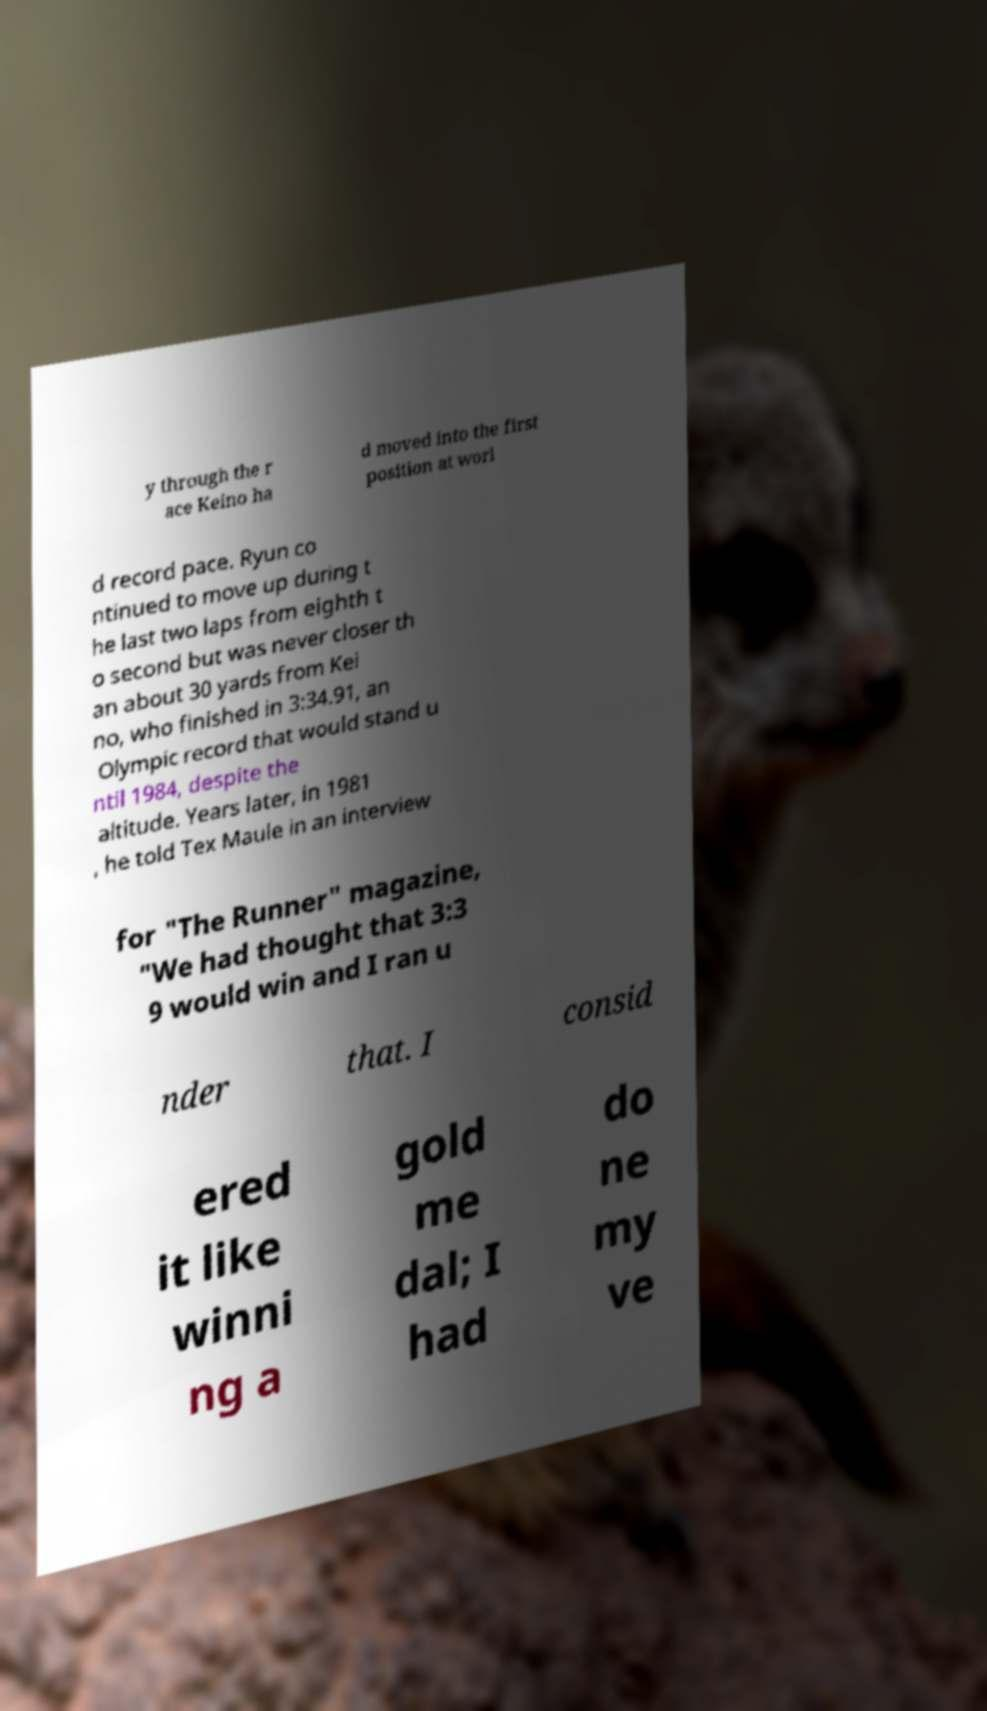Please read and relay the text visible in this image. What does it say? y through the r ace Keino ha d moved into the first position at worl d record pace. Ryun co ntinued to move up during t he last two laps from eighth t o second but was never closer th an about 30 yards from Kei no, who finished in 3:34.91, an Olympic record that would stand u ntil 1984, despite the altitude. Years later, in 1981 , he told Tex Maule in an interview for "The Runner" magazine, "We had thought that 3:3 9 would win and I ran u nder that. I consid ered it like winni ng a gold me dal; I had do ne my ve 